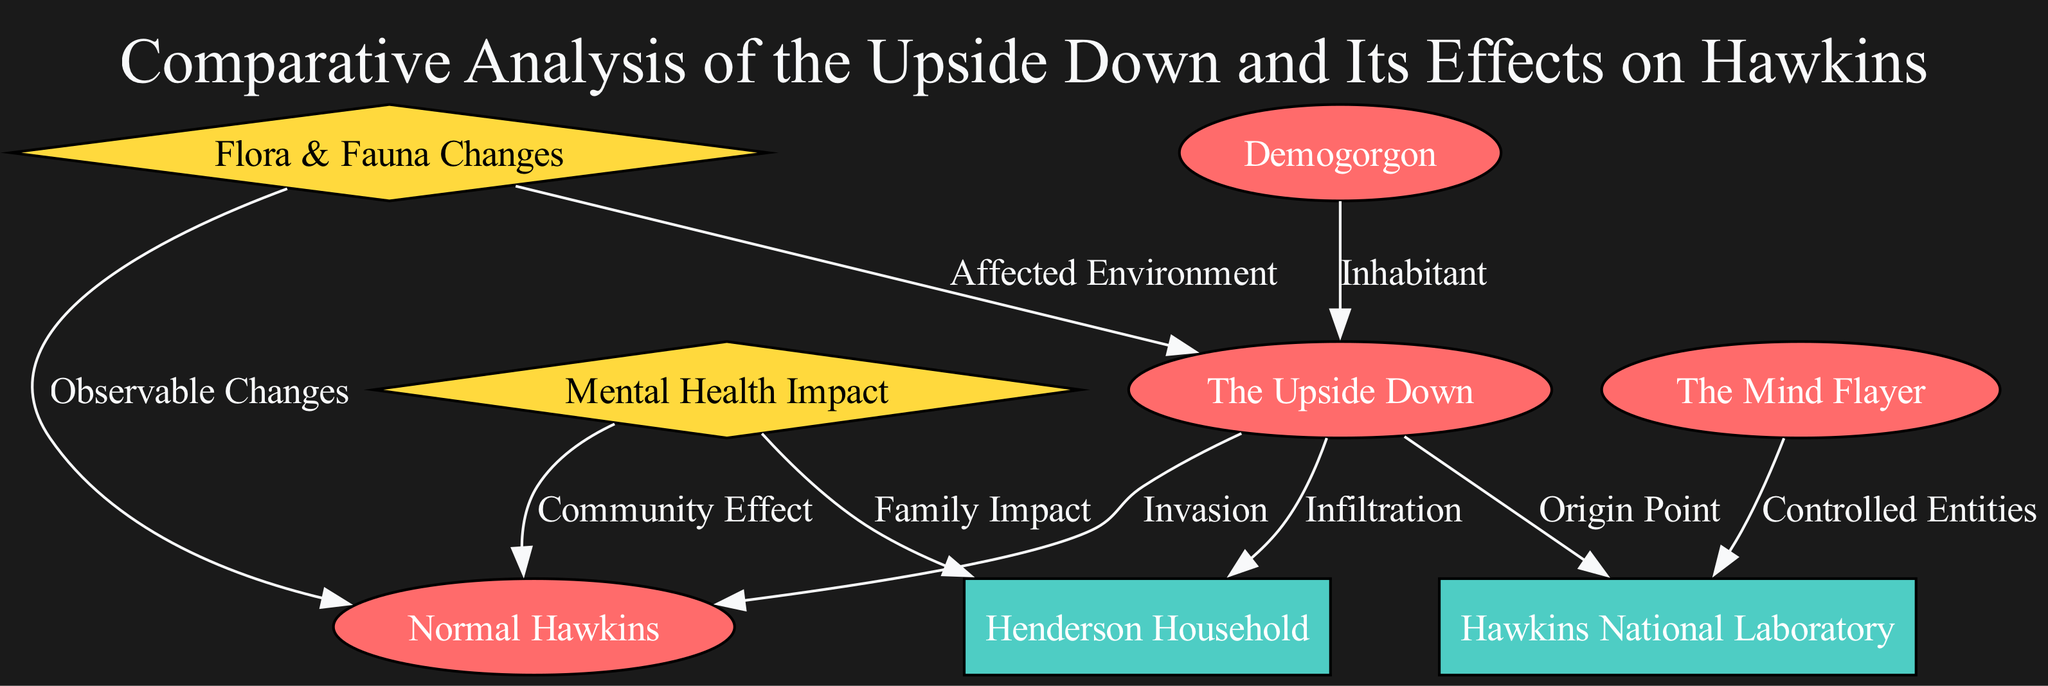What is the relationship between the Upside Down and Normal Hawkins? The diagram indicates that the relationship is labeled "Invasion," showing that the Upside Down has a direct negative impact on Normal Hawkins.
Answer: Invasion How many nodes are present in this diagram? By counting all the unique entities, locations, and phenomena listed, we find there are 8 nodes in total: The Upside Down, Normal Hawkins, Henderson Household, Hawkins National Laboratory, The Mind Flayer, Demogorgon, Flora & Fauna Changes, and Mental Health Impact.
Answer: 8 What effect does the Mind Flayer have on Hawkins National Laboratory? The relationship defined in the diagram is labeled "Controlled Entities," suggesting that the Mind Flayer exerts control over entities in the Hawkins National Laboratory.
Answer: Controlled Entities What two phenomena are affected by the Upside Down? The diagram shows that both "Flora & Fauna Changes" and "Mental Health Impact" are linked to the Upside Down, illustrating its broader effects beyond just the physical environment.
Answer: Flora & Fauna Changes, Mental Health Impact What is the label for the relationship between the flora and fauna changes and the normal Hawkins? According to the diagram, the relationship is labeled "Observable Changes," indicating that inhabitants of Normal Hawkins witness these changes as a result of the Upside Down's influence.
Answer: Observable Changes Which location serves as the origin point for the Upside Down? The diagram explicitly indicates that the "Hawkins National Laboratory" is the origin point for the Upside Down, linking the two directly.
Answer: Hawkins National Laboratory What impact does the Upside Down have on the Henderson Household? The diagram shows that the relationship is labeled "Infiltration," suggesting that the Upside Down infiltrates the Henderson Household, affecting those living there.
Answer: Infiltration Which entity is depicted as an inhabitant of the Upside Down? From the diagram, it is clear that the "Demogorgon" is labeled as an inhabitant, indicating its existence within the Upside Down.
Answer: Demogorgon 